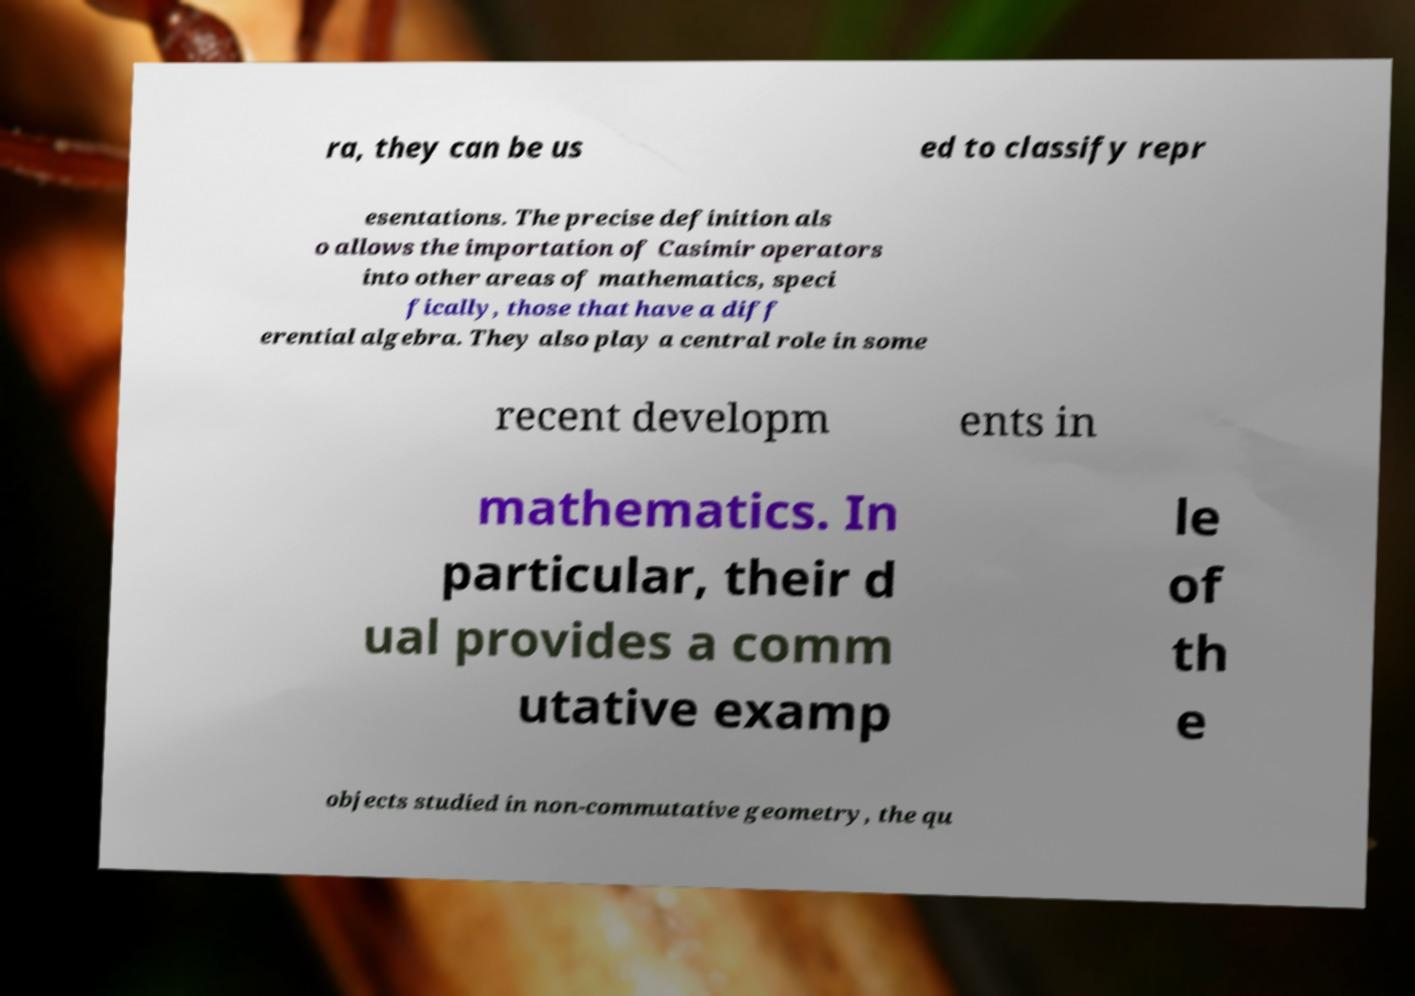Please read and relay the text visible in this image. What does it say? ra, they can be us ed to classify repr esentations. The precise definition als o allows the importation of Casimir operators into other areas of mathematics, speci fically, those that have a diff erential algebra. They also play a central role in some recent developm ents in mathematics. In particular, their d ual provides a comm utative examp le of th e objects studied in non-commutative geometry, the qu 